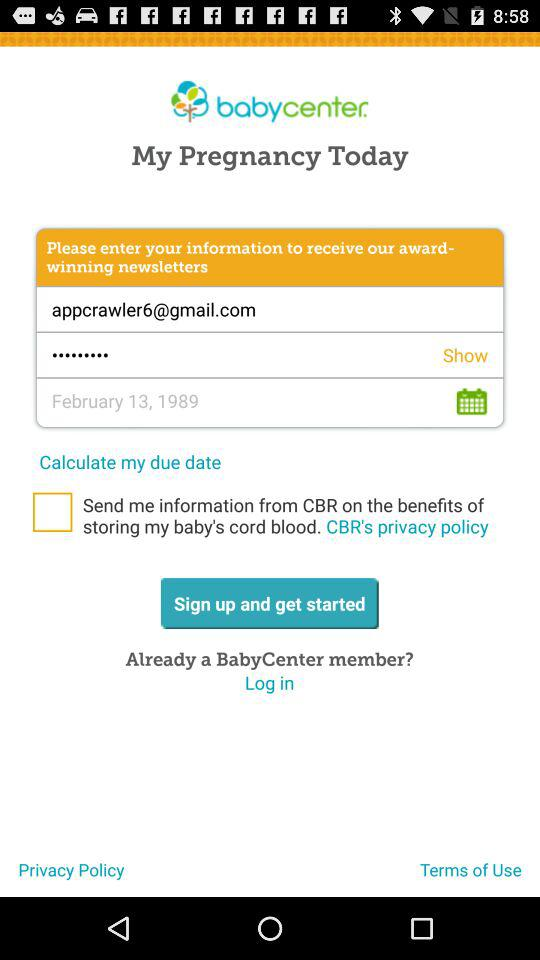What is the date of birth of the user? The date of birth is February 13, 1989. 